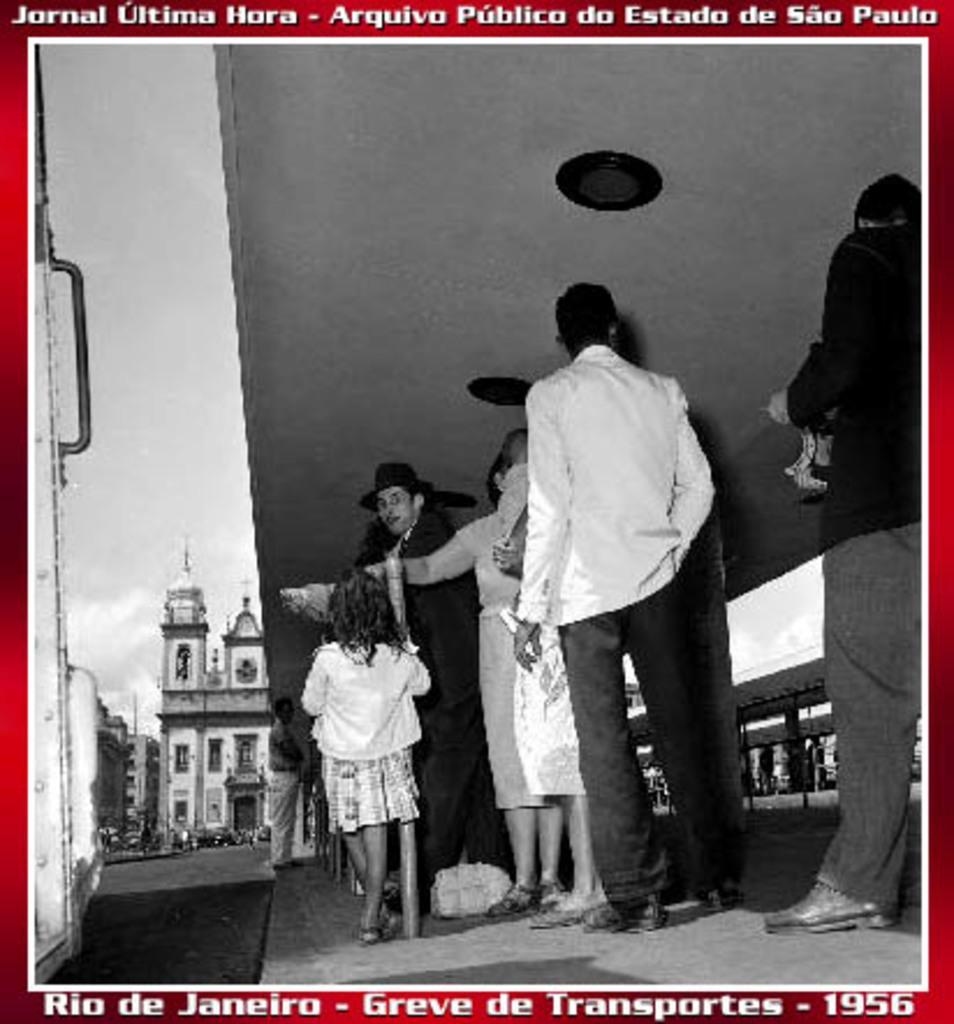Describe this image in one or two sentences. In this picture there is a poster. In the center I can see many people who are standing near to the shed. In the background I can see the cars on the road. Behind that I can see the buildings. On the left I can see the sky and clouds. At the top and bottom I can see the watermarks. 